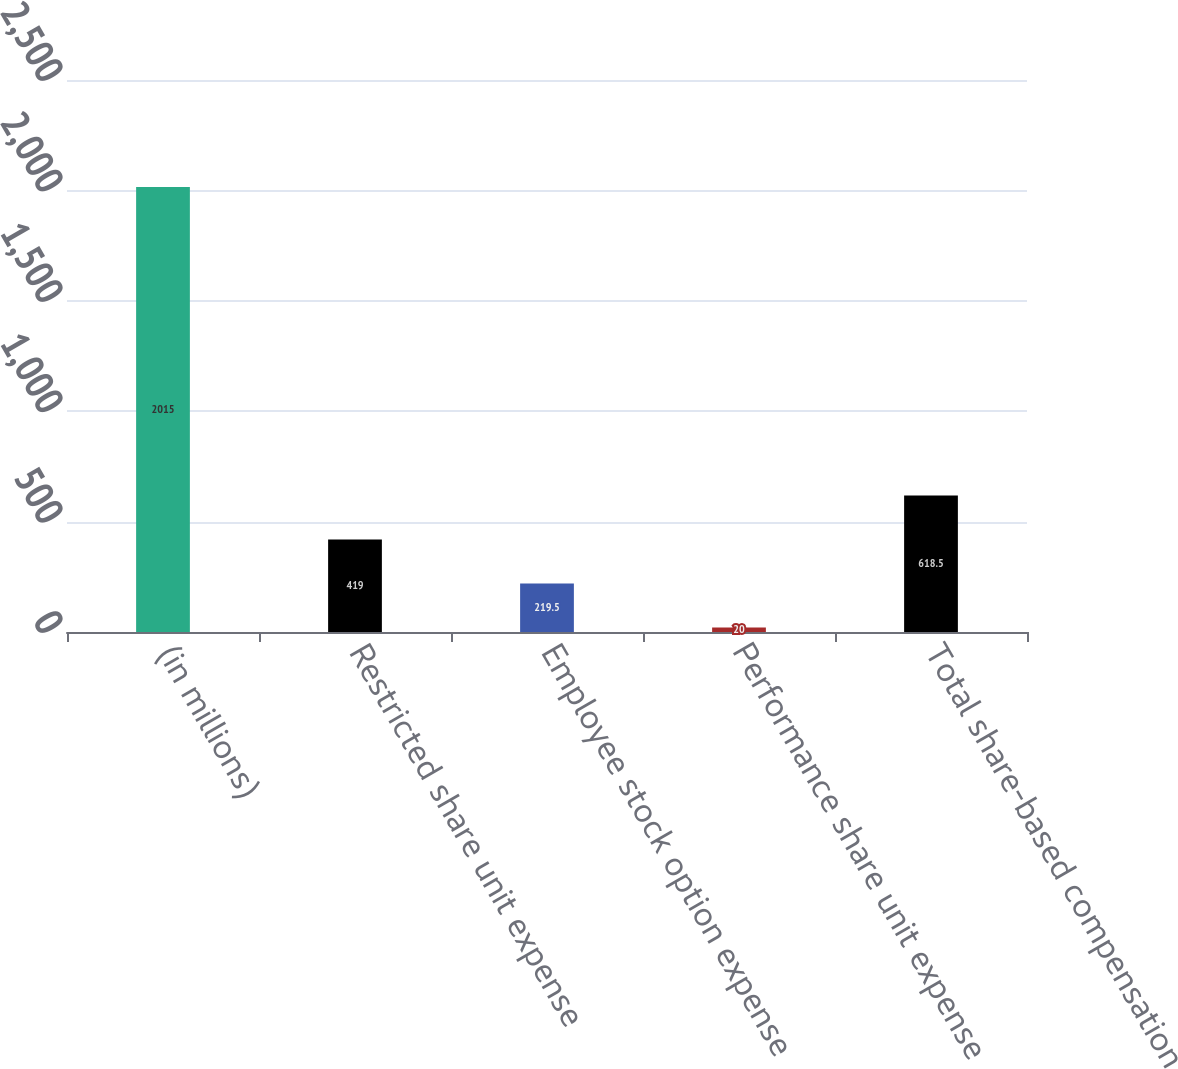Convert chart to OTSL. <chart><loc_0><loc_0><loc_500><loc_500><bar_chart><fcel>(in millions)<fcel>Restricted share unit expense<fcel>Employee stock option expense<fcel>Performance share unit expense<fcel>Total share-based compensation<nl><fcel>2015<fcel>419<fcel>219.5<fcel>20<fcel>618.5<nl></chart> 